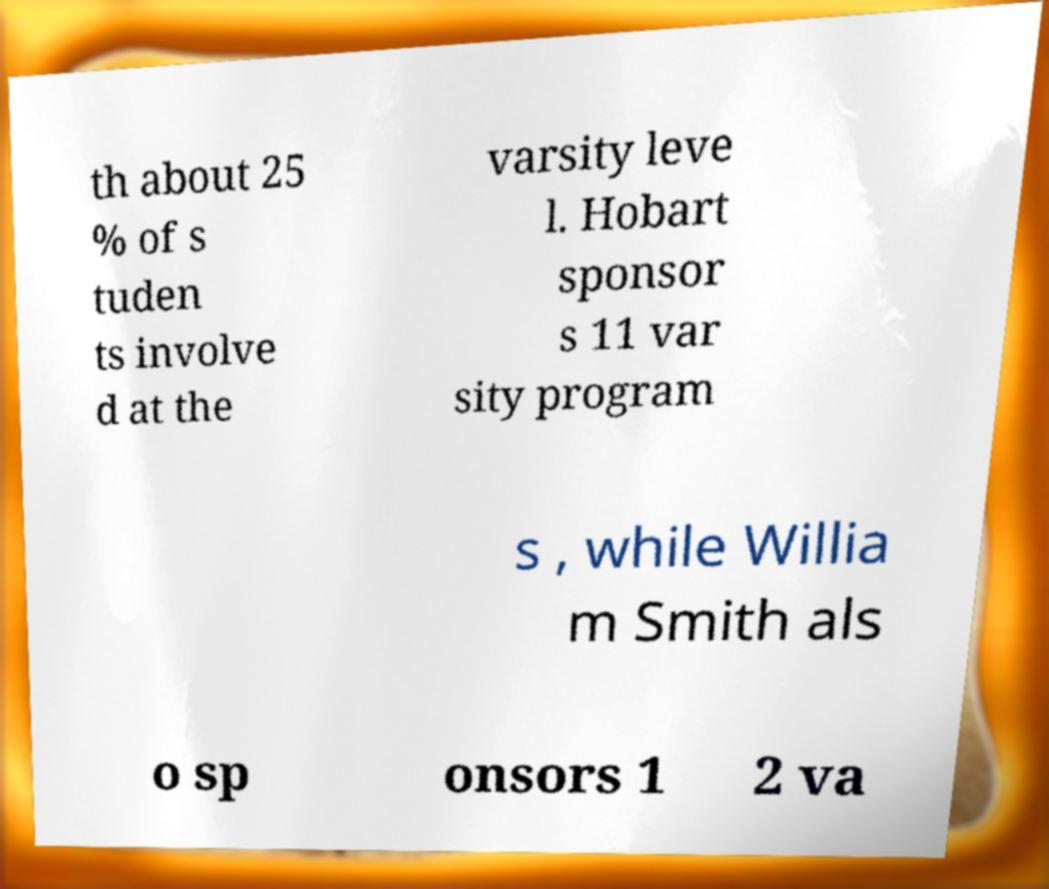There's text embedded in this image that I need extracted. Can you transcribe it verbatim? th about 25 % of s tuden ts involve d at the varsity leve l. Hobart sponsor s 11 var sity program s , while Willia m Smith als o sp onsors 1 2 va 